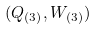<formula> <loc_0><loc_0><loc_500><loc_500>( Q _ { ( 3 ) } , W _ { ( 3 ) } )</formula> 